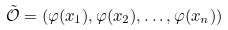<formula> <loc_0><loc_0><loc_500><loc_500>\tilde { \mathcal { O } } = ( \varphi ( x _ { 1 } ) , \varphi ( x _ { 2 } ) , \dots , \varphi ( x _ { n } ) )</formula> 